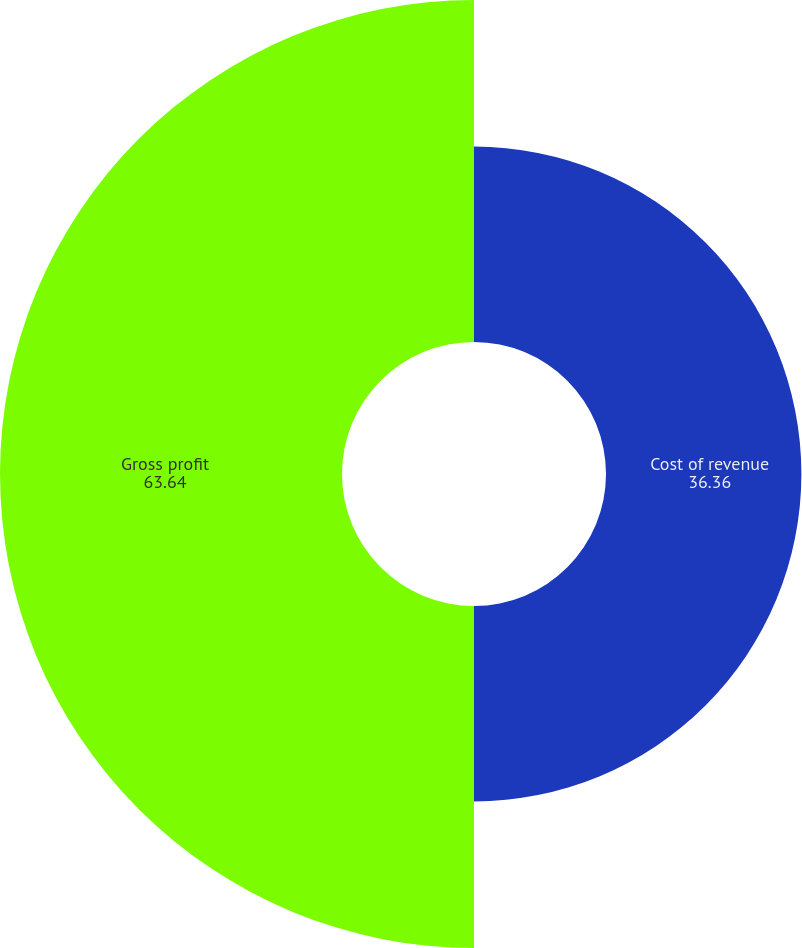Convert chart to OTSL. <chart><loc_0><loc_0><loc_500><loc_500><pie_chart><fcel>Cost of revenue<fcel>Gross profit<nl><fcel>36.36%<fcel>63.64%<nl></chart> 